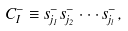<formula> <loc_0><loc_0><loc_500><loc_500>C _ { I } ^ { - } \equiv s ^ { - } _ { j _ { 1 } } s ^ { - } _ { j _ { 2 } } \cdot \cdot \cdot s ^ { - } _ { j _ { l } } ,</formula> 